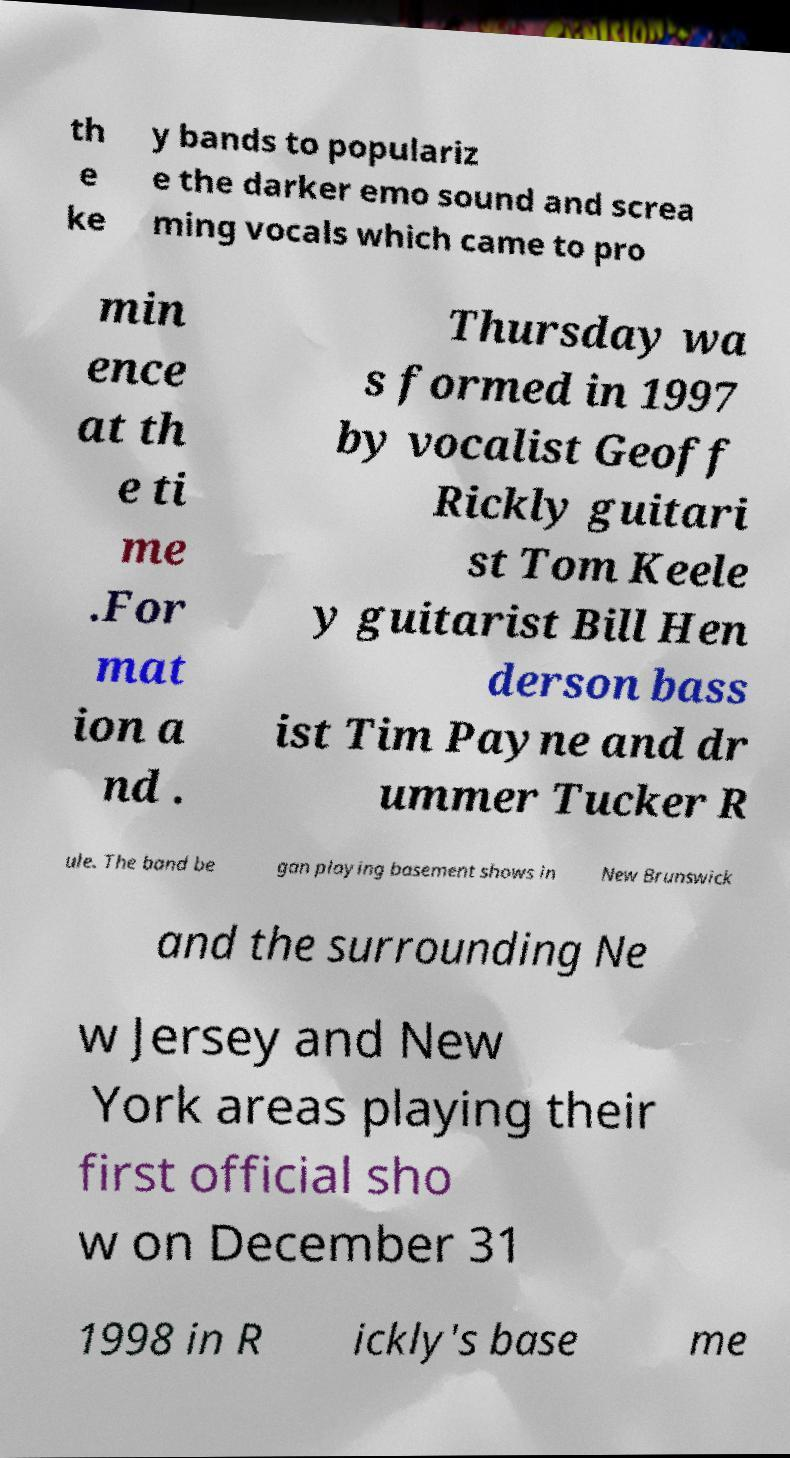Can you accurately transcribe the text from the provided image for me? th e ke y bands to populariz e the darker emo sound and screa ming vocals which came to pro min ence at th e ti me .For mat ion a nd . Thursday wa s formed in 1997 by vocalist Geoff Rickly guitari st Tom Keele y guitarist Bill Hen derson bass ist Tim Payne and dr ummer Tucker R ule. The band be gan playing basement shows in New Brunswick and the surrounding Ne w Jersey and New York areas playing their first official sho w on December 31 1998 in R ickly's base me 